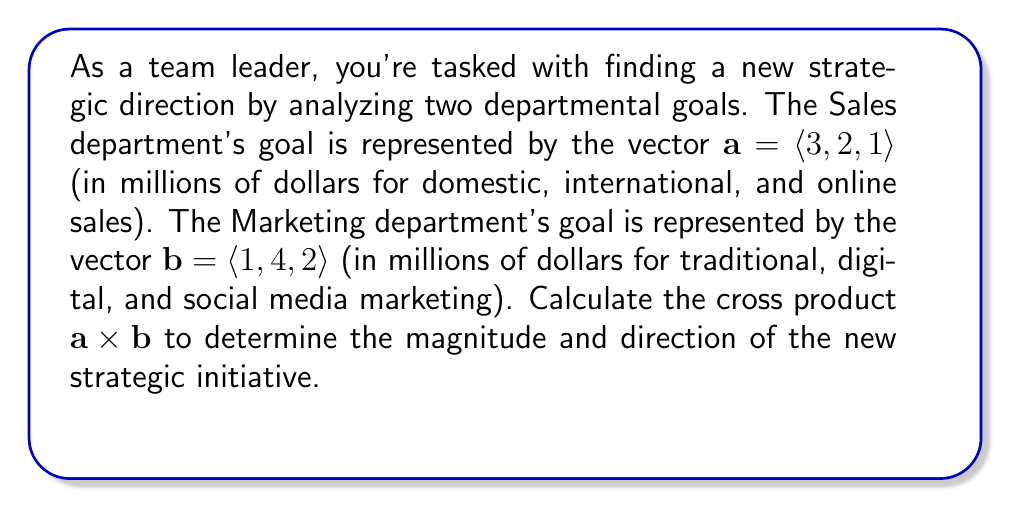What is the answer to this math problem? To calculate the cross product $\mathbf{a} \times \mathbf{b}$, we use the formula:

$$\mathbf{a} \times \mathbf{b} = \langle a_2b_3 - a_3b_2, a_3b_1 - a_1b_3, a_1b_2 - a_2b_1 \rangle$$

Where $\mathbf{a} = \langle a_1, a_2, a_3 \rangle$ and $\mathbf{b} = \langle b_1, b_2, b_3 \rangle$.

Step 1: Identify the components
$\mathbf{a} = \langle 3, 2, 1 \rangle$ and $\mathbf{b} = \langle 1, 4, 2 \rangle$

Step 2: Calculate each component of the cross product
1. $a_2b_3 - a_3b_2 = (2)(2) - (1)(4) = 4 - 4 = 0$
2. $a_3b_1 - a_1b_3 = (1)(1) - (3)(2) = 1 - 6 = -5$
3. $a_1b_2 - a_2b_1 = (3)(4) - (2)(1) = 12 - 2 = 10$

Step 3: Combine the results into a vector
$\mathbf{a} \times \mathbf{b} = \langle 0, -5, 10 \rangle$

Step 4: Calculate the magnitude of the resulting vector
$\|\mathbf{a} \times \mathbf{b}\| = \sqrt{0^2 + (-5)^2 + 10^2} = \sqrt{125} = 5\sqrt{5}$

The magnitude represents the strength of the new strategic initiative, while the direction indicates the relative emphasis on different aspects of the business.
Answer: $\mathbf{a} \times \mathbf{b} = \langle 0, -5, 10 \rangle$, with magnitude $5\sqrt{5}$ million dollars. 